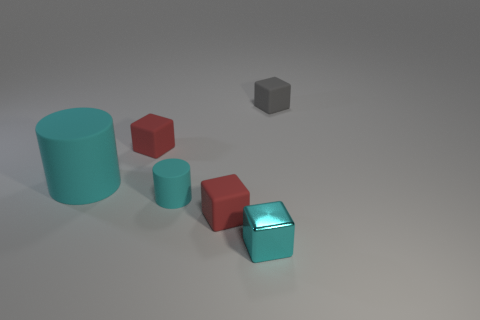What number of other objects are the same material as the large cylinder?
Your answer should be very brief. 4. Is the color of the small matte object that is on the right side of the small cyan shiny object the same as the shiny object?
Offer a terse response. No. There is a small matte cube that is in front of the big rubber cylinder; are there any metallic cubes to the left of it?
Make the answer very short. No. What is the material of the block that is behind the tiny cyan metallic cube and in front of the large cylinder?
Offer a terse response. Rubber. There is a tiny cyan object that is the same material as the gray thing; what shape is it?
Keep it short and to the point. Cylinder. Is there any other thing that has the same shape as the large cyan matte thing?
Make the answer very short. Yes. Does the red cube behind the big cylinder have the same material as the tiny cylinder?
Your answer should be very brief. Yes. What material is the small object that is on the left side of the small cyan cylinder?
Your answer should be compact. Rubber. There is a red cube that is left of the red rubber object in front of the large cylinder; what size is it?
Offer a terse response. Small. How many cyan rubber objects are the same size as the gray rubber block?
Your response must be concise. 1. 